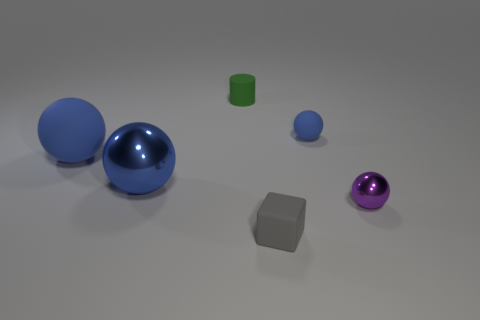Subtract all brown cylinders. How many blue spheres are left? 3 Subtract all gray balls. Subtract all brown cylinders. How many balls are left? 4 Add 3 tiny blue matte balls. How many objects exist? 9 Subtract all balls. How many objects are left? 2 Subtract all big green metal objects. Subtract all tiny rubber cylinders. How many objects are left? 5 Add 2 matte cylinders. How many matte cylinders are left? 3 Add 1 purple objects. How many purple objects exist? 2 Subtract 0 blue cylinders. How many objects are left? 6 